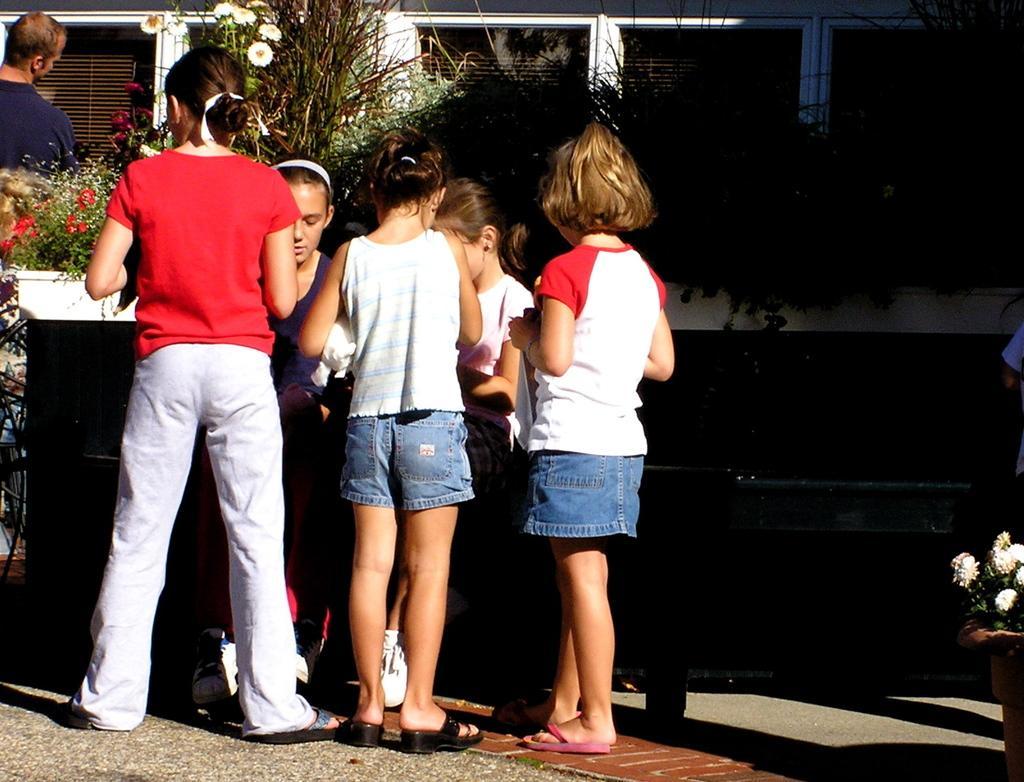How would you summarize this image in a sentence or two? In this image I can see the ground, few persons are standing on the ground, few plants and few flowers which are white, pink and red in color. In the background I can see a building. 